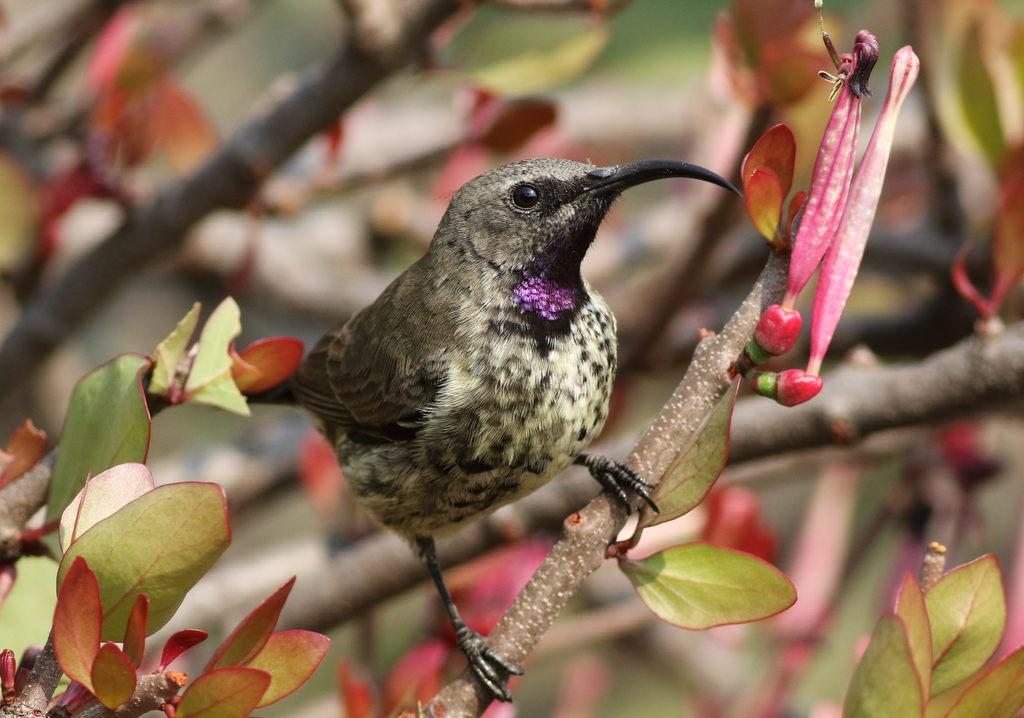What is the main subject of the picture? The main subject of the picture is a bird. Where is the bird located in the picture? The bird is standing on a tree stem. What can be said about the tree in the picture? The tree has leaves. What are the colors of the bird? The bird is black in color and has white shades on it. How many apples can be seen hanging from the tree in the image? There are no apples present in the image; it features a bird standing on a tree stem with leaves. What type of cent is visible in the image? There is no cent present in the image. 